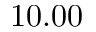<formula> <loc_0><loc_0><loc_500><loc_500>1 0 . 0 0</formula> 